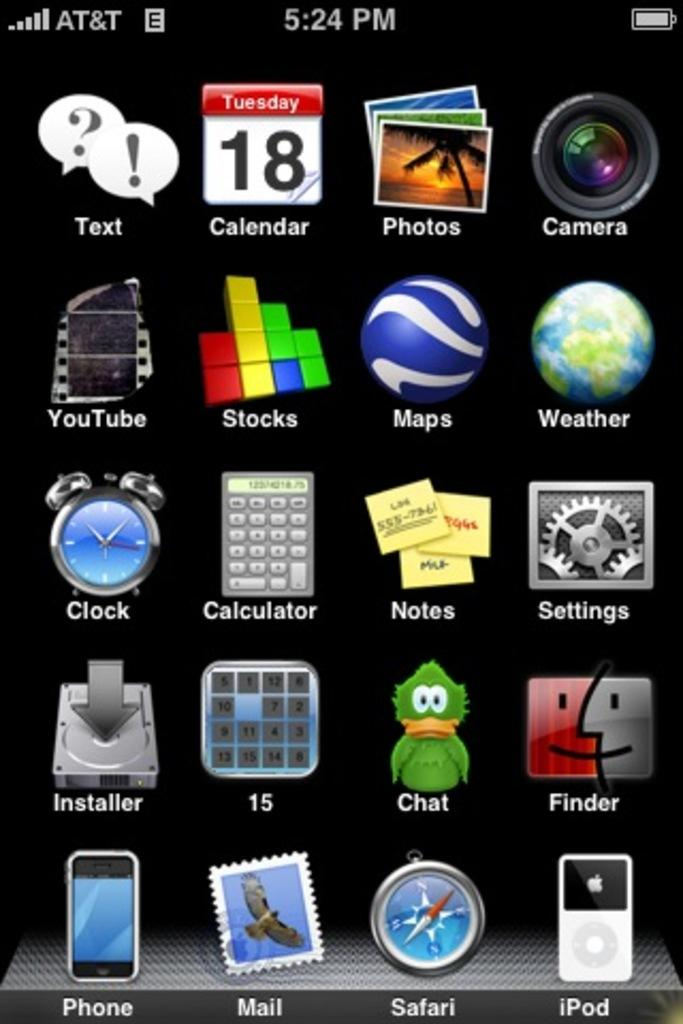<image>
Describe the image concisely. an AT&T network phone screen shot showing icons like Safari and IPod 